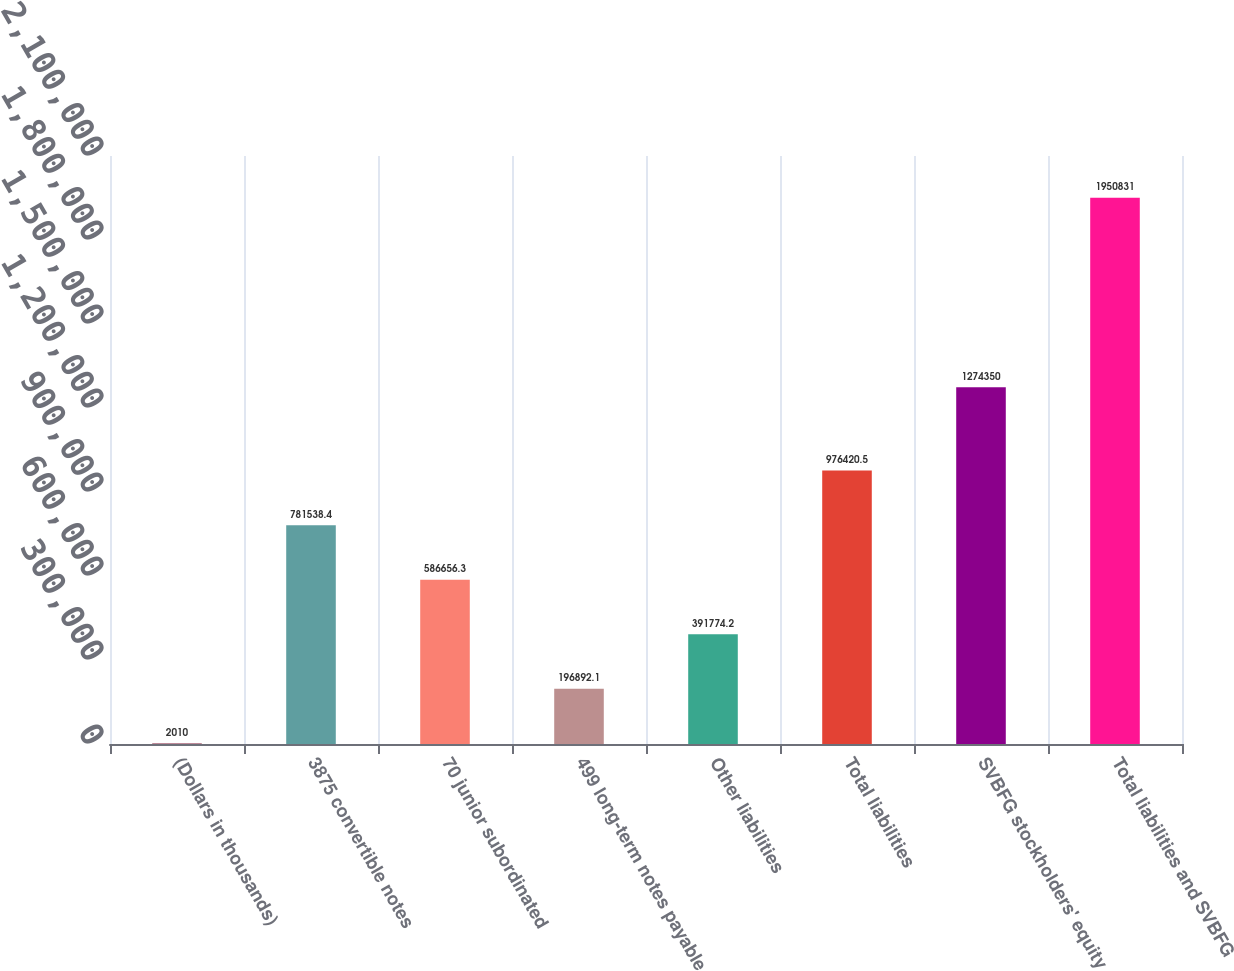Convert chart to OTSL. <chart><loc_0><loc_0><loc_500><loc_500><bar_chart><fcel>(Dollars in thousands)<fcel>3875 convertible notes<fcel>70 junior subordinated<fcel>499 long-term notes payable<fcel>Other liabilities<fcel>Total liabilities<fcel>SVBFG stockholders' equity<fcel>Total liabilities and SVBFG<nl><fcel>2010<fcel>781538<fcel>586656<fcel>196892<fcel>391774<fcel>976420<fcel>1.27435e+06<fcel>1.95083e+06<nl></chart> 